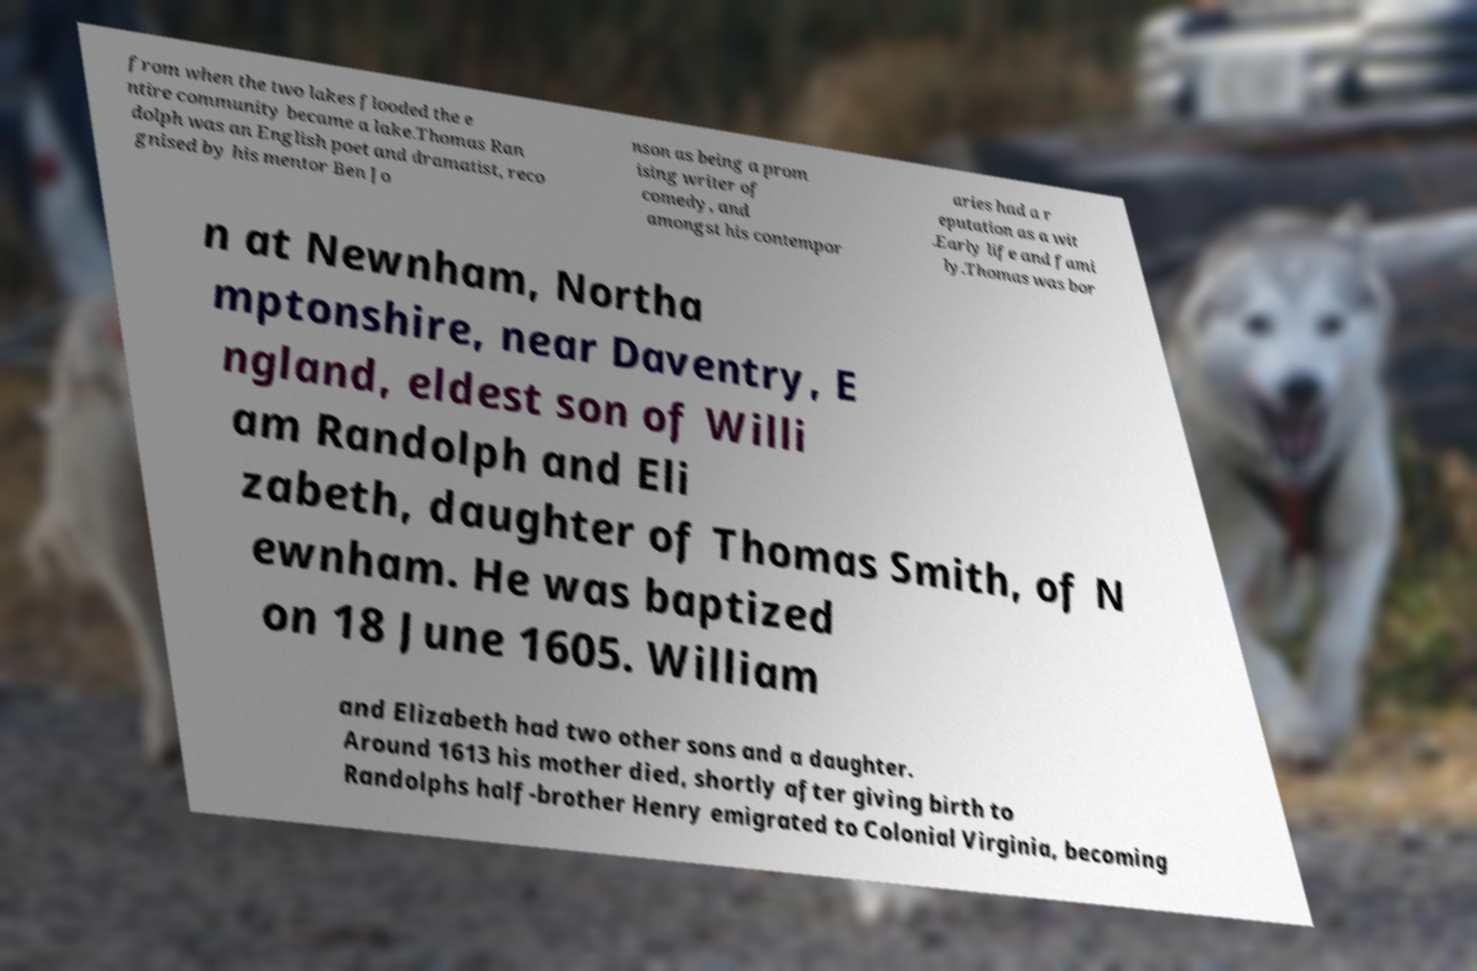There's text embedded in this image that I need extracted. Can you transcribe it verbatim? from when the two lakes flooded the e ntire community became a lake.Thomas Ran dolph was an English poet and dramatist, reco gnised by his mentor Ben Jo nson as being a prom ising writer of comedy, and amongst his contempor aries had a r eputation as a wit .Early life and fami ly.Thomas was bor n at Newnham, Northa mptonshire, near Daventry, E ngland, eldest son of Willi am Randolph and Eli zabeth, daughter of Thomas Smith, of N ewnham. He was baptized on 18 June 1605. William and Elizabeth had two other sons and a daughter. Around 1613 his mother died, shortly after giving birth to Randolphs half-brother Henry emigrated to Colonial Virginia, becoming 